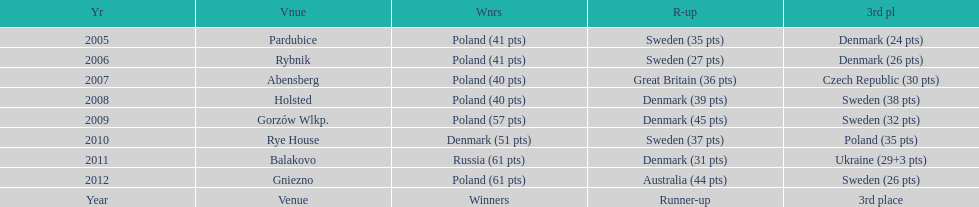What is the total number of points earned in the years 2009? 134. 